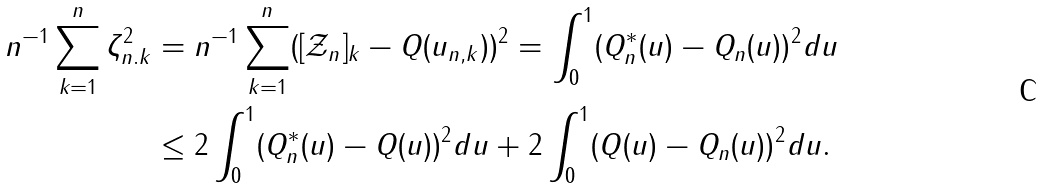<formula> <loc_0><loc_0><loc_500><loc_500>n ^ { - 1 } \sum _ { k = 1 } ^ { n } \zeta _ { n . k } ^ { 2 } & = n ^ { - 1 } \sum _ { k = 1 } ^ { n } ( [ \mathcal { Z } _ { n } ] _ { k } - Q ( u _ { n , k } ) ) ^ { 2 } = \int _ { 0 } ^ { 1 } ( Q ^ { * } _ { n } ( u ) - Q _ { n } ( u ) ) ^ { 2 } d u \\ & \leq 2 \int _ { 0 } ^ { 1 } ( Q ^ { * } _ { n } ( u ) - Q ( u ) ) ^ { 2 } d u + 2 \int _ { 0 } ^ { 1 } ( Q ( u ) - Q _ { n } ( u ) ) ^ { 2 } d u .</formula> 